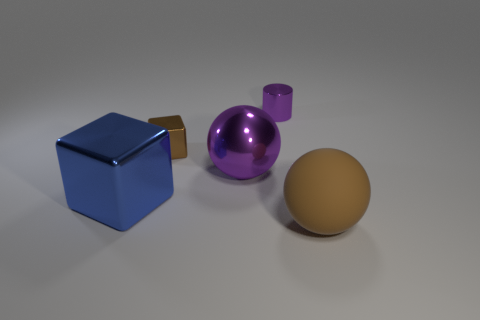Is there anything else that has the same material as the large brown sphere?
Provide a succinct answer. No. There is a big sphere on the left side of the big matte sphere; how many large things are in front of it?
Your answer should be compact. 2. There is a brown object that is behind the object left of the brown metal object; is there a big purple metallic ball that is behind it?
Your answer should be very brief. No. There is another thing that is the same shape as the blue object; what material is it?
Provide a short and direct response. Metal. Is the material of the small block the same as the big ball behind the brown ball?
Provide a short and direct response. Yes. What is the shape of the big metallic object that is behind the big object that is left of the brown block?
Give a very brief answer. Sphere. What number of tiny things are cylinders or blocks?
Keep it short and to the point. 2. What number of other large metallic objects are the same shape as the brown shiny object?
Make the answer very short. 1. Do the blue metal thing and the small thing that is behind the tiny brown block have the same shape?
Ensure brevity in your answer.  No. There is a brown sphere; how many blue objects are in front of it?
Provide a short and direct response. 0. 